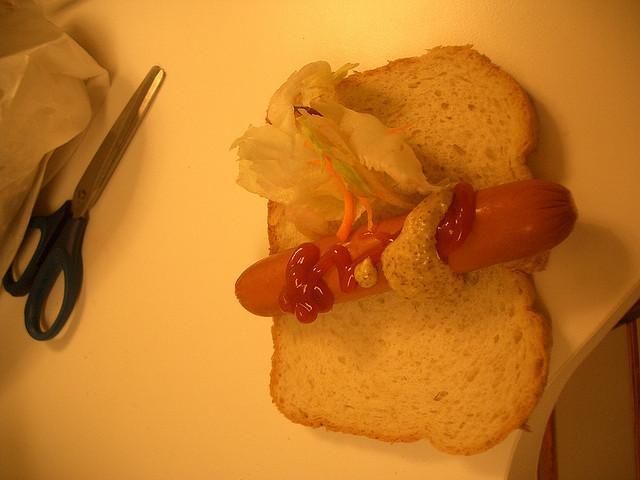How many different vegetables were used to create the red sauce on the hot dog? Please explain your reasoning. one. Ketchup is seen on this hot dog. ketchup is derived from tomatoes and no other vegetables. 